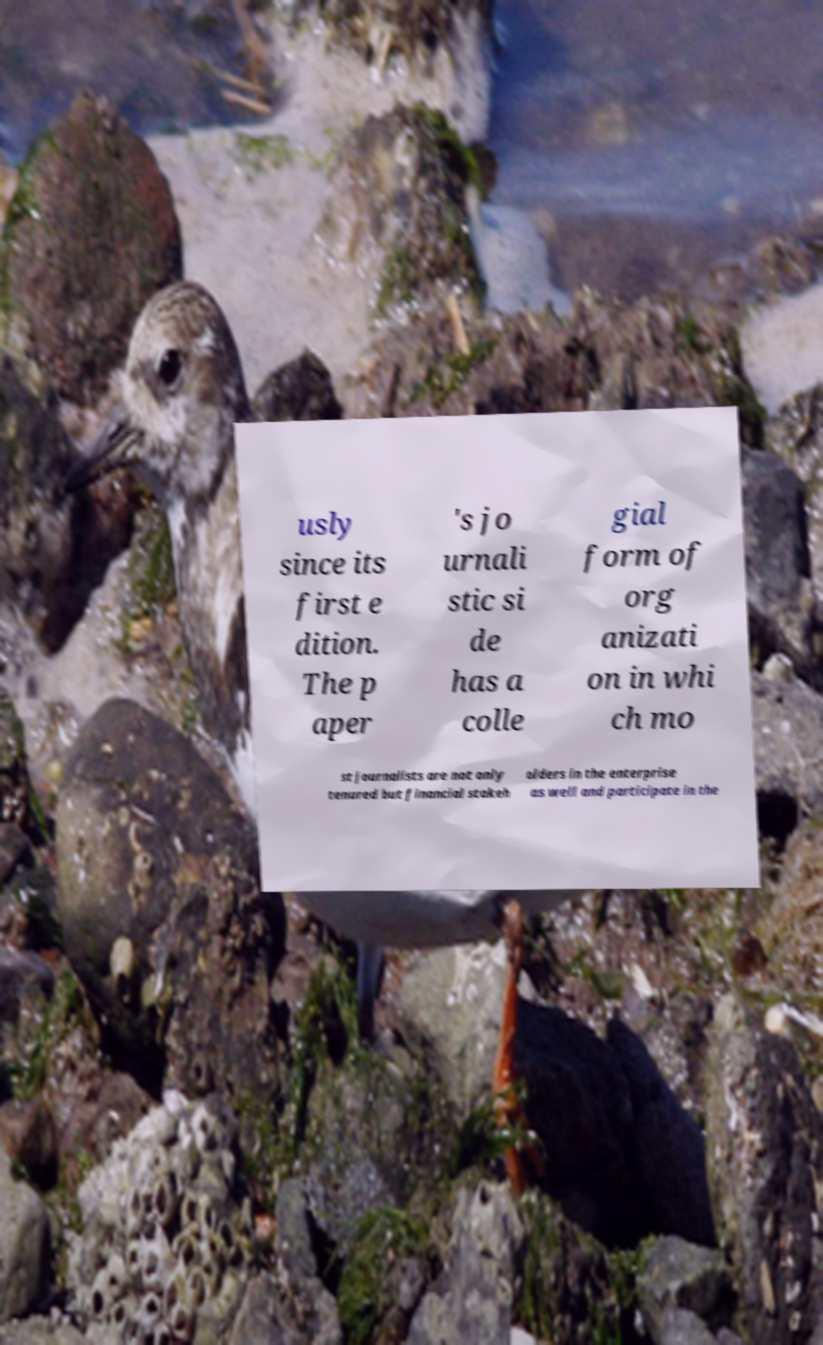For documentation purposes, I need the text within this image transcribed. Could you provide that? usly since its first e dition. The p aper 's jo urnali stic si de has a colle gial form of org anizati on in whi ch mo st journalists are not only tenured but financial stakeh olders in the enterprise as well and participate in the 